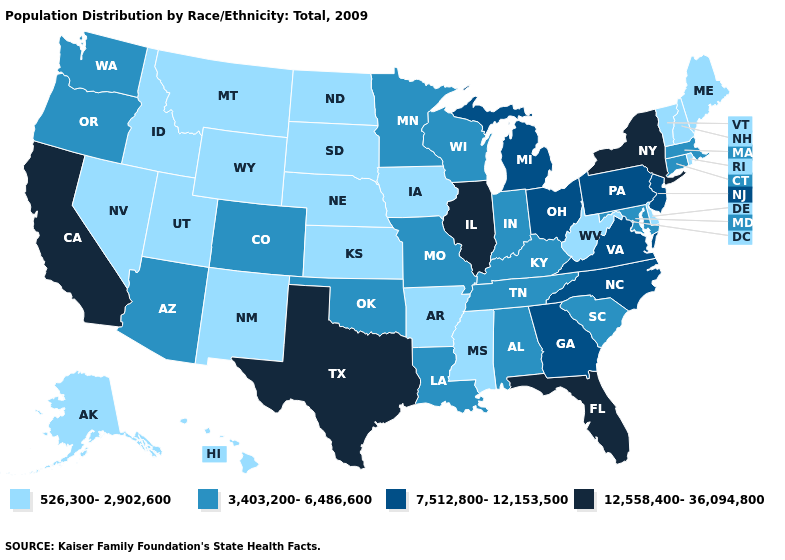Does West Virginia have the lowest value in the South?
Write a very short answer. Yes. Does Hawaii have a lower value than Wyoming?
Be succinct. No. What is the highest value in states that border New Mexico?
Concise answer only. 12,558,400-36,094,800. Which states have the lowest value in the MidWest?
Answer briefly. Iowa, Kansas, Nebraska, North Dakota, South Dakota. Does South Dakota have the lowest value in the USA?
Keep it brief. Yes. What is the lowest value in the USA?
Short answer required. 526,300-2,902,600. What is the lowest value in states that border Arkansas?
Quick response, please. 526,300-2,902,600. What is the value of Arizona?
Give a very brief answer. 3,403,200-6,486,600. Does Wisconsin have the same value as Florida?
Be succinct. No. Does Ohio have a lower value than Illinois?
Concise answer only. Yes. Is the legend a continuous bar?
Short answer required. No. Does Illinois have the same value as Delaware?
Answer briefly. No. Which states have the lowest value in the West?
Write a very short answer. Alaska, Hawaii, Idaho, Montana, Nevada, New Mexico, Utah, Wyoming. What is the lowest value in the USA?
Short answer required. 526,300-2,902,600. What is the value of Nebraska?
Short answer required. 526,300-2,902,600. 